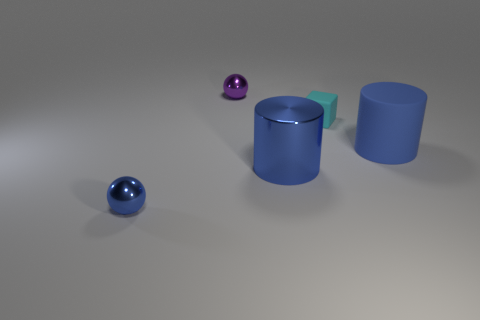What material is the blue cylinder that is on the left side of the blue rubber object?
Your answer should be very brief. Metal. There is a blue thing that is the same shape as the tiny purple metallic object; what is its material?
Offer a terse response. Metal. Are there any shiny cylinders that are left of the large blue cylinder that is left of the cyan rubber thing?
Offer a terse response. No. Does the small matte object have the same shape as the small purple object?
Your answer should be compact. No. What is the shape of the small purple object that is the same material as the blue ball?
Provide a short and direct response. Sphere. Do the ball that is behind the large blue shiny thing and the blue matte cylinder to the right of the blue ball have the same size?
Your answer should be compact. No. Is the number of purple metal spheres that are right of the rubber cylinder greater than the number of tiny spheres that are on the right side of the metal cylinder?
Your answer should be compact. No. How many other things are there of the same color as the metallic cylinder?
Keep it short and to the point. 2. There is a matte cylinder; does it have the same color as the large cylinder to the left of the cyan block?
Provide a succinct answer. Yes. How many blue metal balls are on the left side of the tiny shiny object that is in front of the large shiny cylinder?
Make the answer very short. 0. 